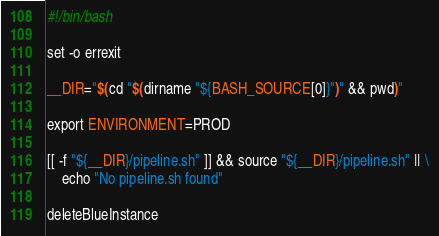Convert code to text. <code><loc_0><loc_0><loc_500><loc_500><_Bash_>#!/bin/bash

set -o errexit

__DIR="$(cd "$(dirname "${BASH_SOURCE[0]}")" && pwd)"

export ENVIRONMENT=PROD

[[ -f "${__DIR}/pipeline.sh" ]] && source "${__DIR}/pipeline.sh" || \
    echo "No pipeline.sh found"

deleteBlueInstance
</code> 